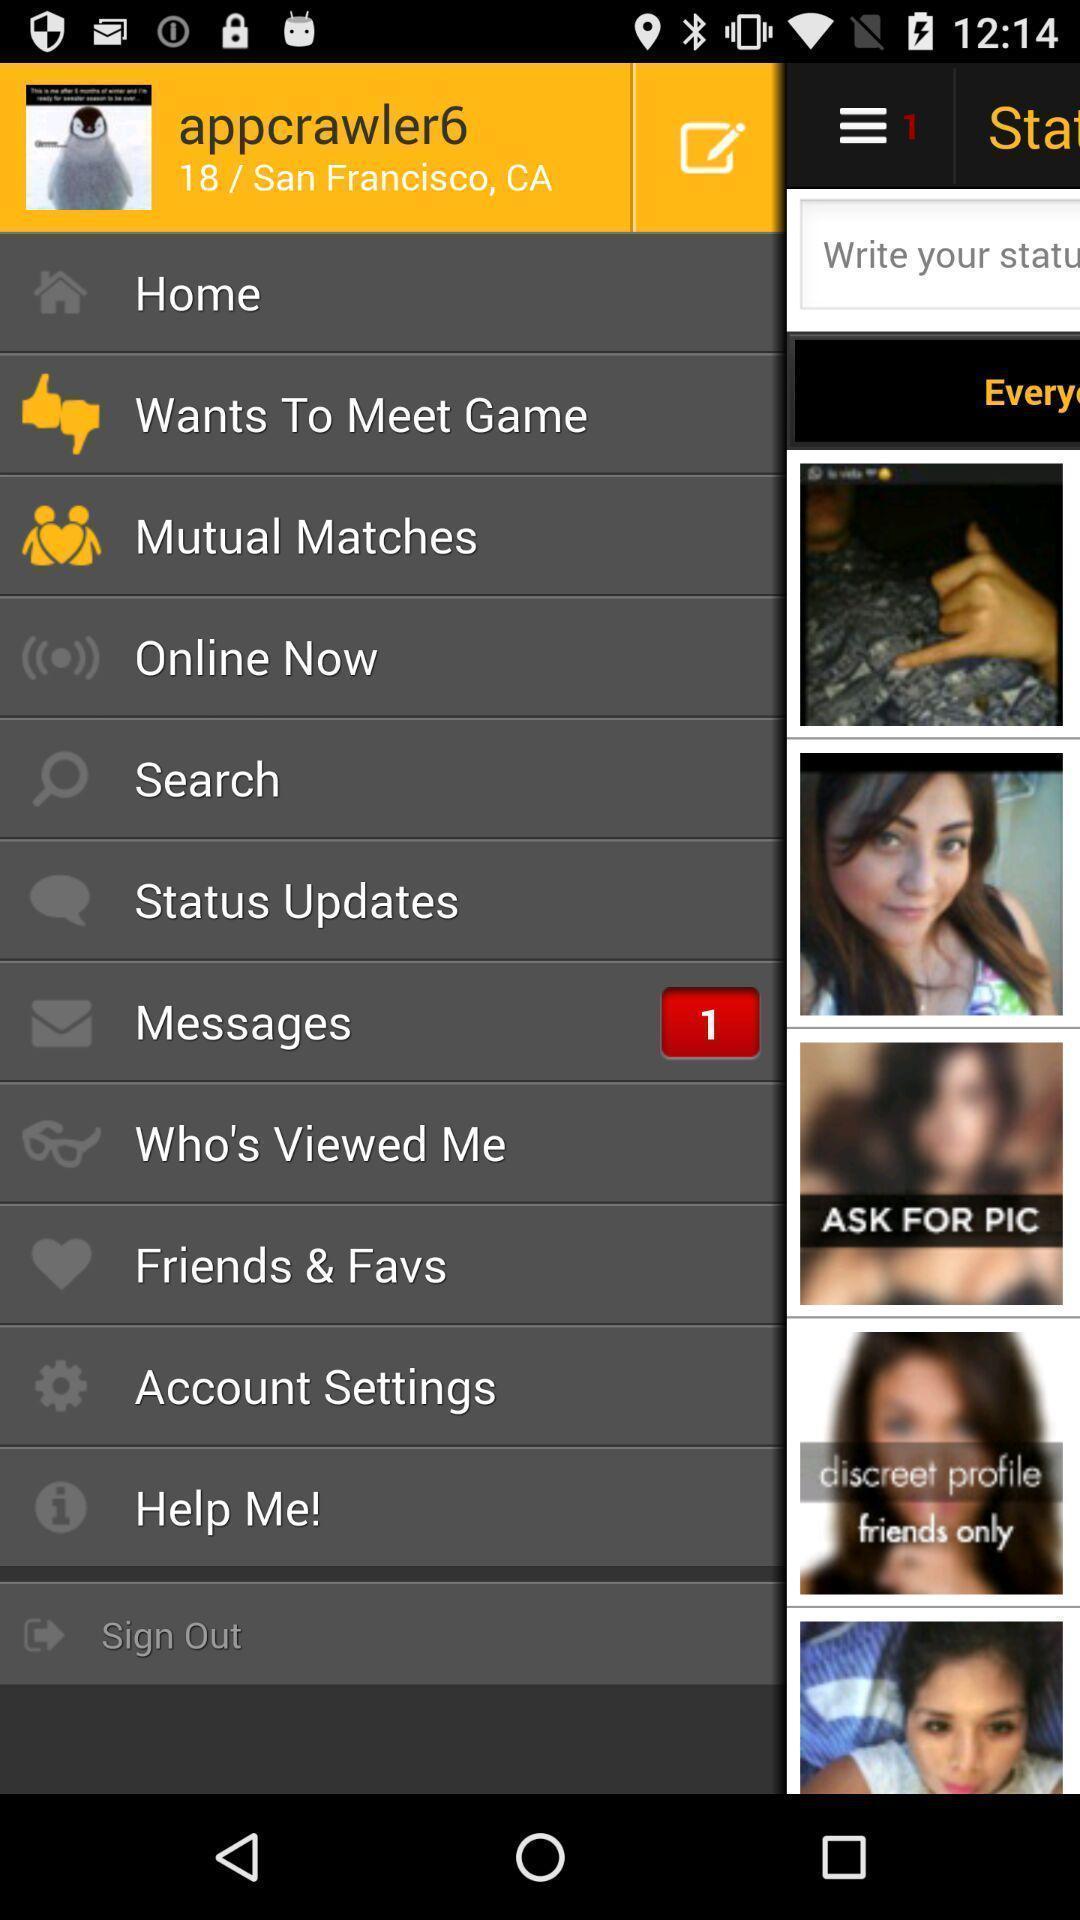Explain what's happening in this screen capture. Page showing home page in a device. 